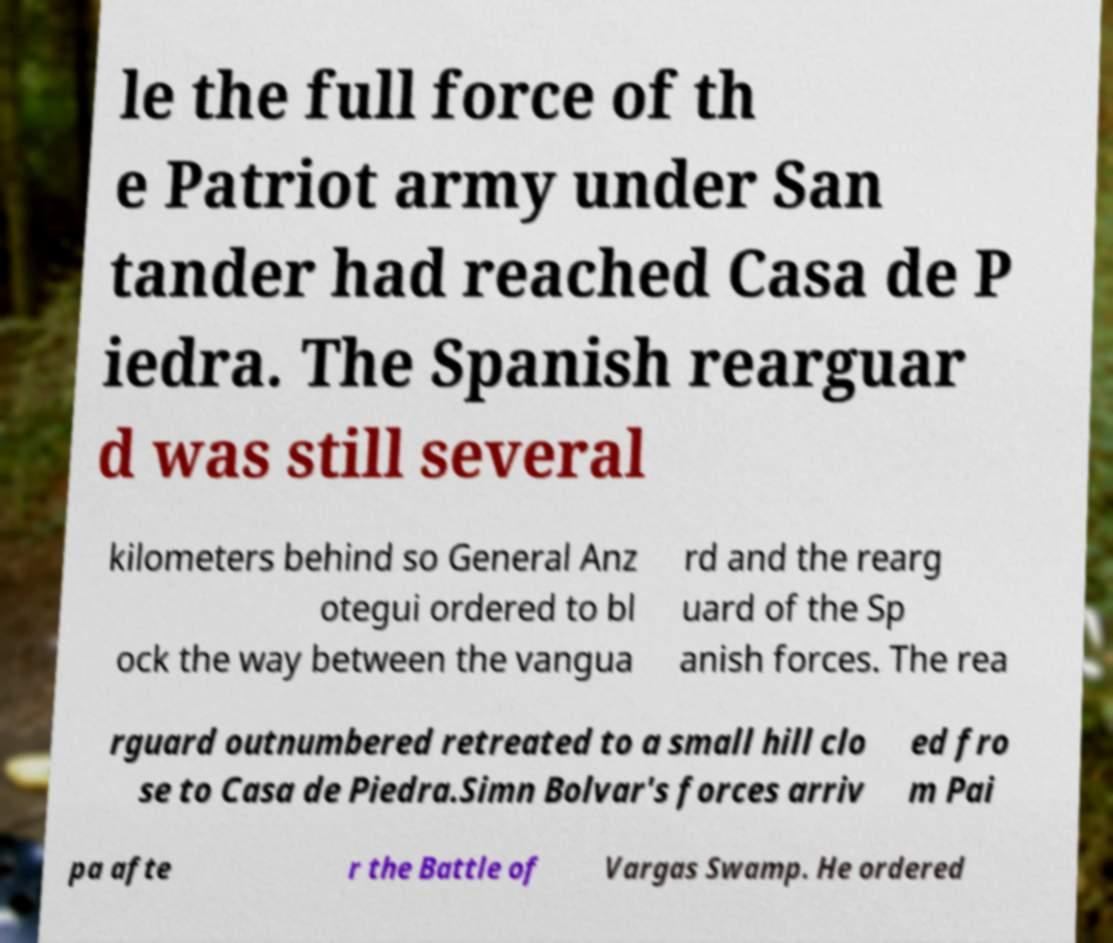Could you assist in decoding the text presented in this image and type it out clearly? le the full force of th e Patriot army under San tander had reached Casa de P iedra. The Spanish rearguar d was still several kilometers behind so General Anz otegui ordered to bl ock the way between the vangua rd and the rearg uard of the Sp anish forces. The rea rguard outnumbered retreated to a small hill clo se to Casa de Piedra.Simn Bolvar's forces arriv ed fro m Pai pa afte r the Battle of Vargas Swamp. He ordered 